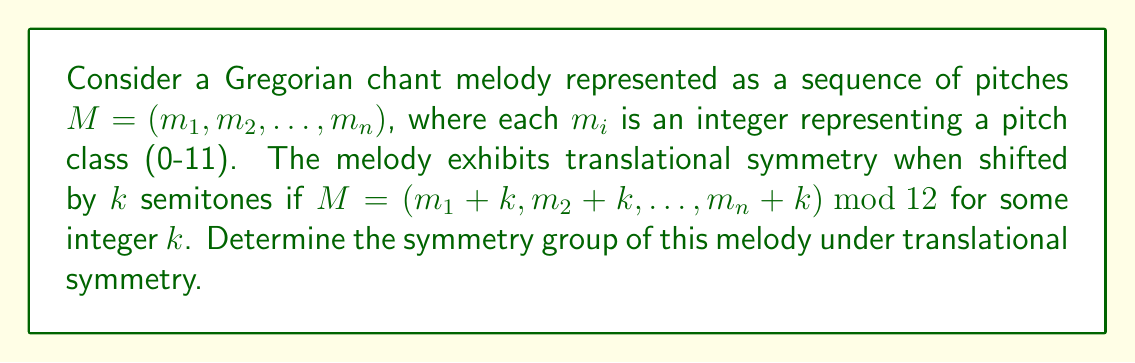Show me your answer to this math problem. To determine the symmetry group of the Gregorian chant melody under translational symmetry, we need to follow these steps:

1) First, we need to identify all possible translations that leave the melody unchanged modulo 12. Let's call this set of translations $T$.

2) For any translation $t \in T$, we have:
   $$(m_1 + t, m_2 + t, ..., m_n + t) \equiv (m_1, m_2, ..., m_n) \pmod{12}$$

3) The set $T$ forms a subgroup of $\mathbb{Z}_{12}$ (the group of integers modulo 12) under addition.

4) The order of this subgroup must divide the order of $\mathbb{Z}_{12}$, which is 12. Therefore, the possible orders for $T$ are 1, 2, 3, 4, 6, or 12.

5) Each of these possible orders corresponds to a unique subgroup of $\mathbb{Z}_{12}$:
   - Order 1: $\{0\}$
   - Order 2: $\{0, 6\}$
   - Order 3: $\{0, 4, 8\}$
   - Order 4: $\{0, 3, 6, 9\}$
   - Order 6: $\{0, 2, 4, 6, 8, 10\}$
   - Order 12: $\mathbb{Z}_{12}$

6) The symmetry group of the melody is isomorphic to the subgroup $T$.

7) Therefore, the symmetry group is cyclic and isomorphic to $\mathbb{Z}_d$, where $d$ is the order of $T$.
Answer: $\mathbb{Z}_d$, where $d \in \{1, 2, 3, 4, 6, 12\}$ 